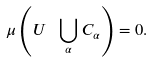<formula> <loc_0><loc_0><loc_500><loc_500>\mu \left ( U \ \bigcup _ { \alpha } C _ { \alpha } \right ) = 0 .</formula> 